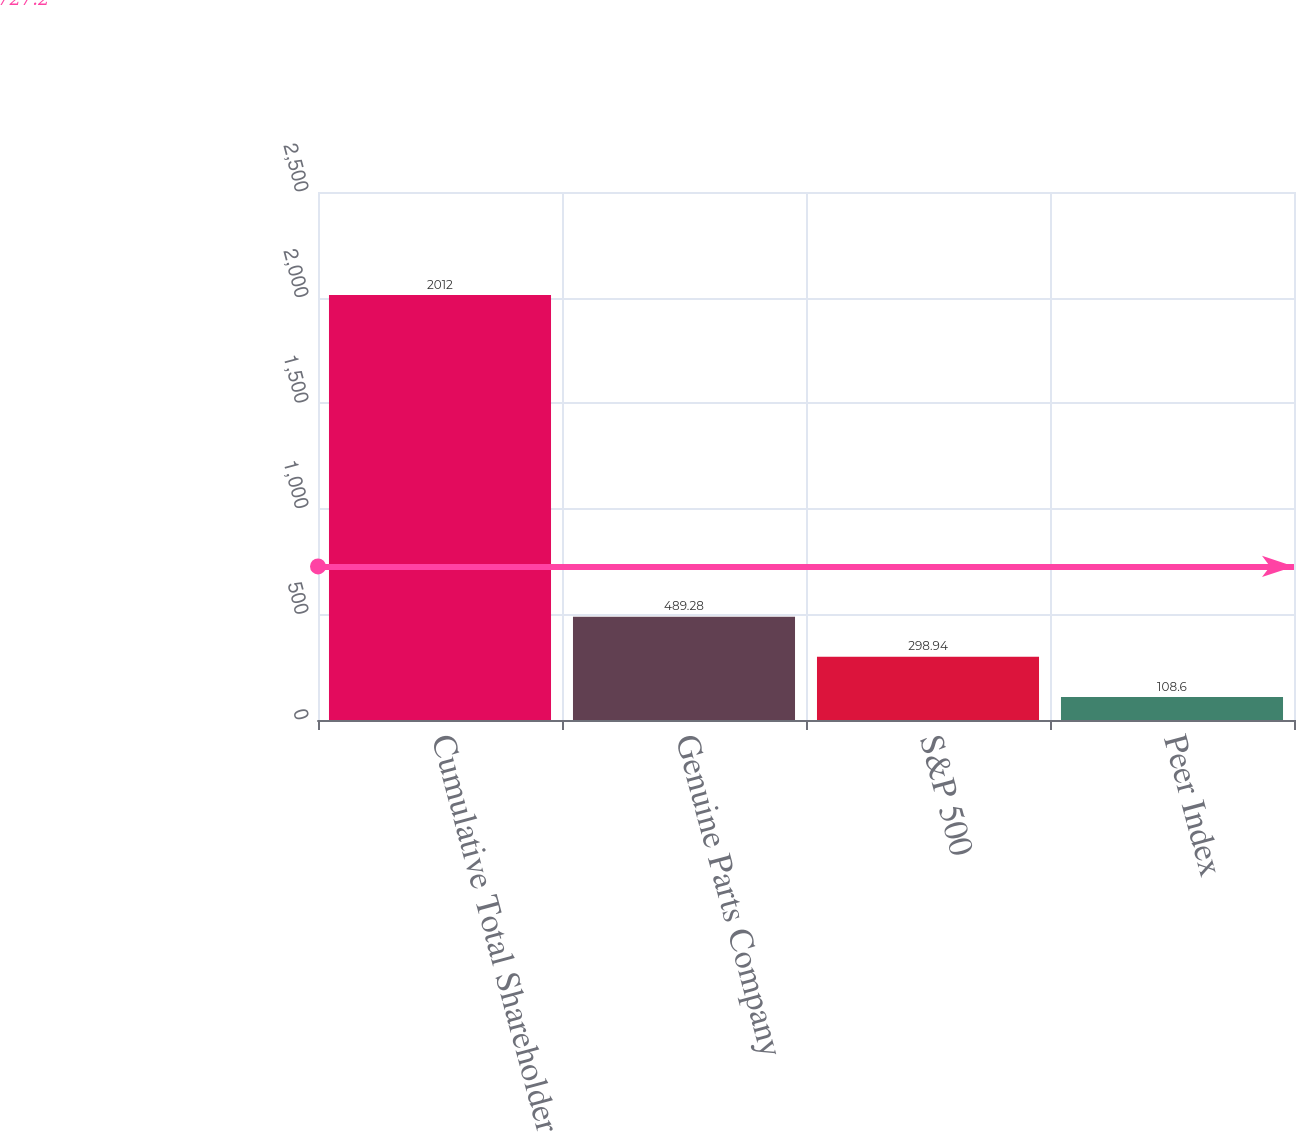<chart> <loc_0><loc_0><loc_500><loc_500><bar_chart><fcel>Cumulative Total Shareholder<fcel>Genuine Parts Company<fcel>S&P 500<fcel>Peer Index<nl><fcel>2012<fcel>489.28<fcel>298.94<fcel>108.6<nl></chart> 